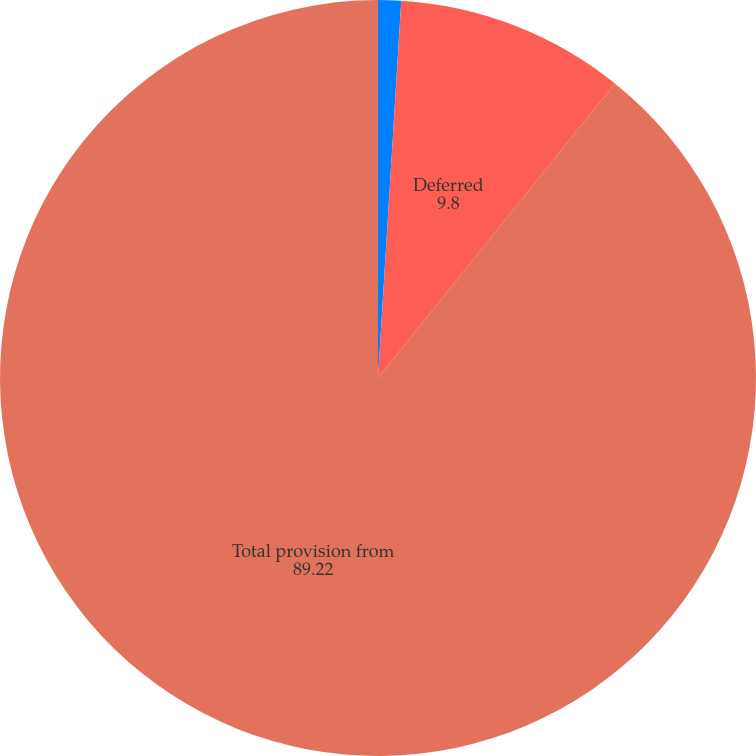Convert chart. <chart><loc_0><loc_0><loc_500><loc_500><pie_chart><fcel>Current<fcel>Deferred<fcel>Total provision from<nl><fcel>0.98%<fcel>9.8%<fcel>89.22%<nl></chart> 